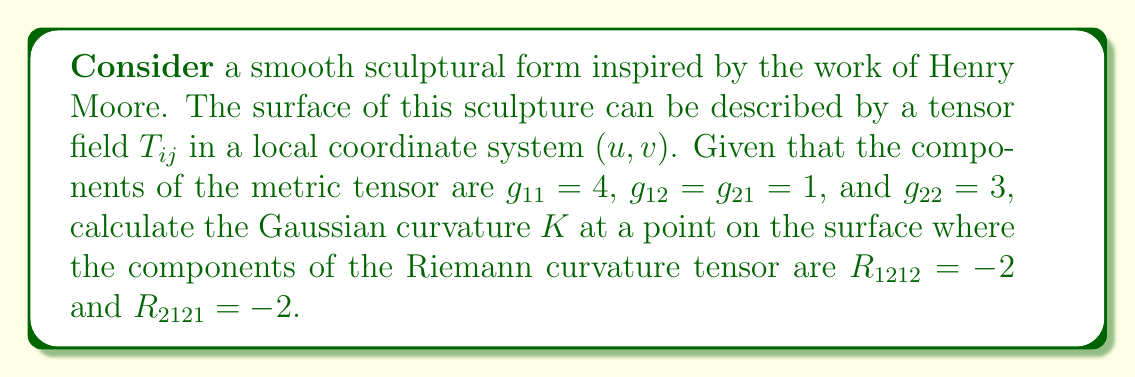What is the answer to this math problem? To calculate the Gaussian curvature $K$ of the sculptural form, we'll follow these steps:

1) The Gaussian curvature $K$ is defined as the ratio of the determinant of the Riemann curvature tensor to the determinant of the metric tensor:

   $$K = \frac{\det(R_{ijkl})}{\det(g_{ij})}$$

2) First, let's calculate the determinant of the metric tensor:
   
   $$\det(g_{ij}) = \begin{vmatrix} 
   g_{11} & g_{12} \\
   g_{21} & g_{22}
   \end{vmatrix} = (4)(3) - (1)(1) = 11$$

3) Now, we need to calculate the determinant of the Riemann curvature tensor. In a 2D surface, there's only one independent component of the Riemann tensor, which is $R_{1212}$. The other non-zero component $R_{2121}$ is equal to $R_{1212}$. Therefore:

   $$\det(R_{ijkl}) = (R_{1212})^2 = (-2)^2 = 4$$

4) Now we can substitute these values into our formula for Gaussian curvature:

   $$K = \frac{\det(R_{ijkl})}{\det(g_{ij})} = \frac{4}{11}$$

This gives us the Gaussian curvature at the specified point on the sculptural surface.
Answer: $K = \frac{4}{11}$ 